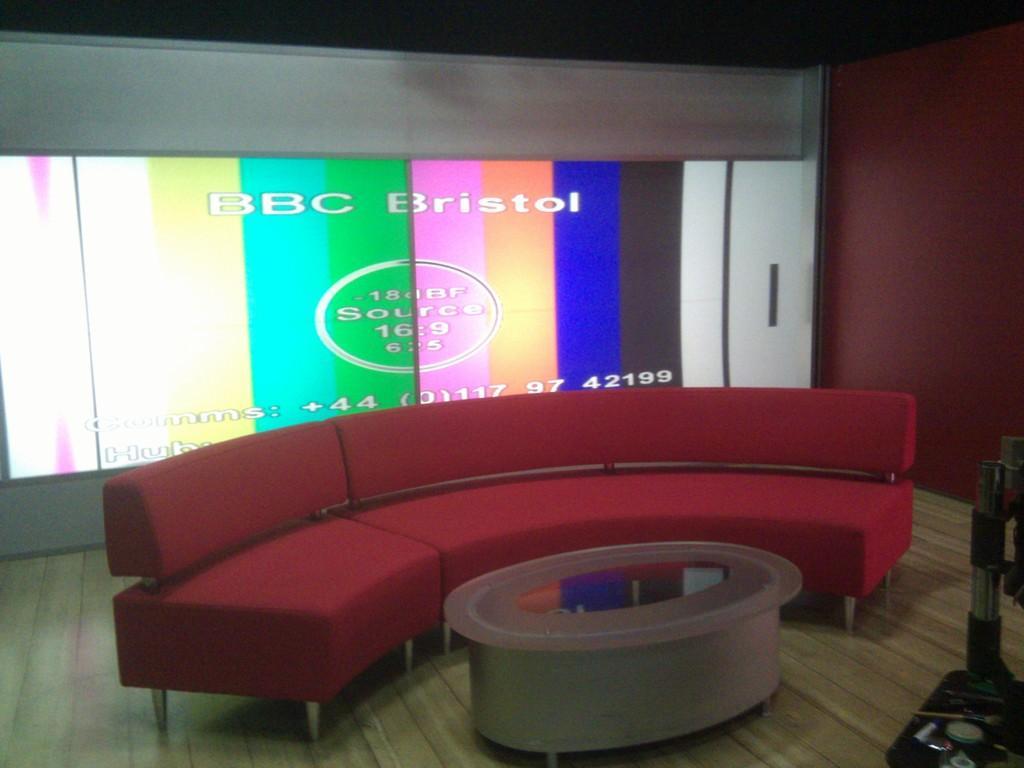In one or two sentences, can you explain what this image depicts? In this picture there is a red color sofa at the center of the image and there is a table in front of that , there is a projector screen at the left side of the image. 